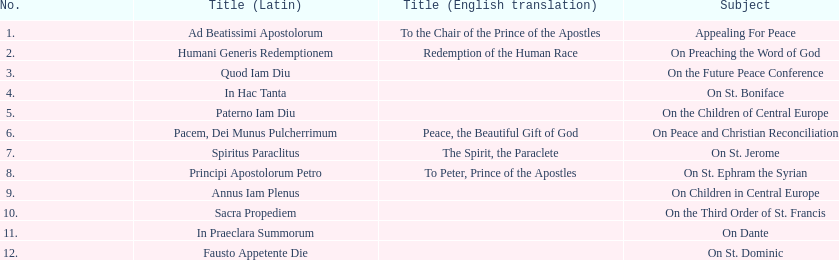Following 1 december 1918, when was the subsequent encyclical? 14 May 1919. Give me the full table as a dictionary. {'header': ['No.', 'Title (Latin)', 'Title (English translation)', 'Subject'], 'rows': [['1.', 'Ad Beatissimi Apostolorum', 'To the Chair of the Prince of the Apostles', 'Appealing For Peace'], ['2.', 'Humani Generis Redemptionem', 'Redemption of the Human Race', 'On Preaching the Word of God'], ['3.', 'Quod Iam Diu', '', 'On the Future Peace Conference'], ['4.', 'In Hac Tanta', '', 'On St. Boniface'], ['5.', 'Paterno Iam Diu', '', 'On the Children of Central Europe'], ['6.', 'Pacem, Dei Munus Pulcherrimum', 'Peace, the Beautiful Gift of God', 'On Peace and Christian Reconciliation'], ['7.', 'Spiritus Paraclitus', 'The Spirit, the Paraclete', 'On St. Jerome'], ['8.', 'Principi Apostolorum Petro', 'To Peter, Prince of the Apostles', 'On St. Ephram the Syrian'], ['9.', 'Annus Iam Plenus', '', 'On Children in Central Europe'], ['10.', 'Sacra Propediem', '', 'On the Third Order of St. Francis'], ['11.', 'In Praeclara Summorum', '', 'On Dante'], ['12.', 'Fausto Appetente Die', '', 'On St. Dominic']]} 